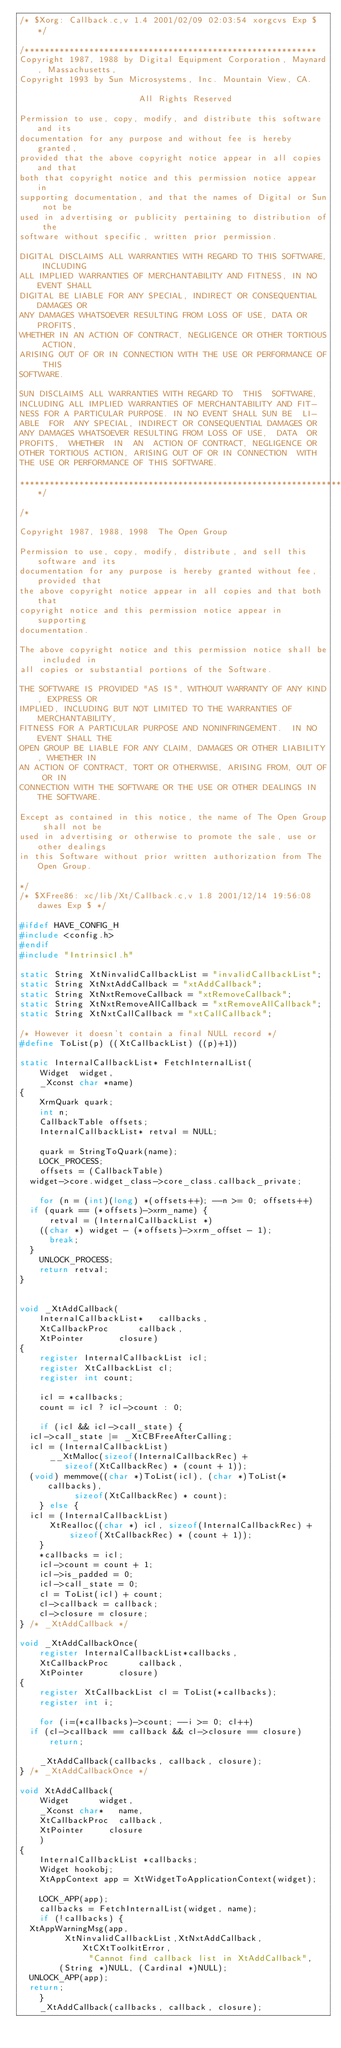<code> <loc_0><loc_0><loc_500><loc_500><_C_>/* $Xorg: Callback.c,v 1.4 2001/02/09 02:03:54 xorgcvs Exp $ */

/***********************************************************
Copyright 1987, 1988 by Digital Equipment Corporation, Maynard, Massachusetts,
Copyright 1993 by Sun Microsystems, Inc. Mountain View, CA.

                        All Rights Reserved

Permission to use, copy, modify, and distribute this software and its
documentation for any purpose and without fee is hereby granted,
provided that the above copyright notice appear in all copies and that
both that copyright notice and this permission notice appear in
supporting documentation, and that the names of Digital or Sun not be
used in advertising or publicity pertaining to distribution of the
software without specific, written prior permission.

DIGITAL DISCLAIMS ALL WARRANTIES WITH REGARD TO THIS SOFTWARE, INCLUDING
ALL IMPLIED WARRANTIES OF MERCHANTABILITY AND FITNESS, IN NO EVENT SHALL
DIGITAL BE LIABLE FOR ANY SPECIAL, INDIRECT OR CONSEQUENTIAL DAMAGES OR
ANY DAMAGES WHATSOEVER RESULTING FROM LOSS OF USE, DATA OR PROFITS,
WHETHER IN AN ACTION OF CONTRACT, NEGLIGENCE OR OTHER TORTIOUS ACTION,
ARISING OUT OF OR IN CONNECTION WITH THE USE OR PERFORMANCE OF THIS
SOFTWARE.

SUN DISCLAIMS ALL WARRANTIES WITH REGARD TO  THIS  SOFTWARE,
INCLUDING ALL IMPLIED WARRANTIES OF MERCHANTABILITY AND FIT-
NESS FOR A PARTICULAR PURPOSE. IN NO EVENT SHALL SUN BE  LI-
ABLE  FOR  ANY SPECIAL, INDIRECT OR CONSEQUENTIAL DAMAGES OR
ANY DAMAGES WHATSOEVER RESULTING FROM LOSS OF USE,  DATA  OR
PROFITS,  WHETHER  IN  AN  ACTION OF CONTRACT, NEGLIGENCE OR
OTHER TORTIOUS ACTION, ARISING OUT OF OR IN CONNECTION  WITH
THE USE OR PERFORMANCE OF THIS SOFTWARE.

******************************************************************/

/*

Copyright 1987, 1988, 1998  The Open Group

Permission to use, copy, modify, distribute, and sell this software and its
documentation for any purpose is hereby granted without fee, provided that
the above copyright notice appear in all copies and that both that
copyright notice and this permission notice appear in supporting
documentation.

The above copyright notice and this permission notice shall be included in
all copies or substantial portions of the Software.

THE SOFTWARE IS PROVIDED "AS IS", WITHOUT WARRANTY OF ANY KIND, EXPRESS OR
IMPLIED, INCLUDING BUT NOT LIMITED TO THE WARRANTIES OF MERCHANTABILITY,
FITNESS FOR A PARTICULAR PURPOSE AND NONINFRINGEMENT.  IN NO EVENT SHALL THE
OPEN GROUP BE LIABLE FOR ANY CLAIM, DAMAGES OR OTHER LIABILITY, WHETHER IN
AN ACTION OF CONTRACT, TORT OR OTHERWISE, ARISING FROM, OUT OF OR IN
CONNECTION WITH THE SOFTWARE OR THE USE OR OTHER DEALINGS IN THE SOFTWARE.

Except as contained in this notice, the name of The Open Group shall not be
used in advertising or otherwise to promote the sale, use or other dealings
in this Software without prior written authorization from The Open Group.

*/
/* $XFree86: xc/lib/Xt/Callback.c,v 1.8 2001/12/14 19:56:08 dawes Exp $ */

#ifdef HAVE_CONFIG_H
#include <config.h>
#endif
#include "IntrinsicI.h"

static String XtNinvalidCallbackList = "invalidCallbackList";
static String XtNxtAddCallback = "xtAddCallback";
static String XtNxtRemoveCallback = "xtRemoveCallback";
static String XtNxtRemoveAllCallback = "xtRemoveAllCallback";
static String XtNxtCallCallback = "xtCallCallback";

/* However it doesn't contain a final NULL record */
#define ToList(p) ((XtCallbackList) ((p)+1))

static InternalCallbackList* FetchInternalList(
    Widget	widget,
    _Xconst char *name)
{
    XrmQuark quark;
    int n;
    CallbackTable offsets;
    InternalCallbackList* retval = NULL;

    quark = StringToQuark(name);
    LOCK_PROCESS;
    offsets = (CallbackTable)
	widget->core.widget_class->core_class.callback_private;

    for (n = (int)(long) *(offsets++); --n >= 0; offsets++)
	if (quark == (*offsets)->xrm_name) {
	    retval = (InternalCallbackList *)
		((char *) widget - (*offsets)->xrm_offset - 1);
	    break;
	}
    UNLOCK_PROCESS;
    return retval;
}


void _XtAddCallback(
    InternalCallbackList*   callbacks,
    XtCallbackProc	    callback,
    XtPointer		    closure)
{
    register InternalCallbackList icl;
    register XtCallbackList cl;
    register int count;

    icl = *callbacks;
    count = icl ? icl->count : 0;

    if (icl && icl->call_state) {
	icl->call_state |= _XtCBFreeAfterCalling;
	icl = (InternalCallbackList)
	    __XtMalloc(sizeof(InternalCallbackRec) +
		     sizeof(XtCallbackRec) * (count + 1));
	(void) memmove((char *)ToList(icl), (char *)ToList(*callbacks),
		       sizeof(XtCallbackRec) * count);
    } else {
	icl = (InternalCallbackList)
	    XtRealloc((char *) icl, sizeof(InternalCallbackRec) +
		      sizeof(XtCallbackRec) * (count + 1));
    }
    *callbacks = icl;
    icl->count = count + 1;
    icl->is_padded = 0;
    icl->call_state = 0;
    cl = ToList(icl) + count;
    cl->callback = callback;
    cl->closure = closure;
} /* _XtAddCallback */

void _XtAddCallbackOnce(
    register InternalCallbackList*callbacks,
    XtCallbackProc	    callback,
    XtPointer		    closure)
{
    register XtCallbackList cl = ToList(*callbacks);
    register int i;

    for (i=(*callbacks)->count; --i >= 0; cl++)
	if (cl->callback == callback && cl->closure == closure)
	    return;

    _XtAddCallback(callbacks, callback, closure);
} /* _XtAddCallbackOnce */

void XtAddCallback(
    Widget	    widget,
    _Xconst char*   name,
    XtCallbackProc  callback,
    XtPointer	    closure
    )
{
    InternalCallbackList *callbacks;
    Widget hookobj;
    XtAppContext app = XtWidgetToApplicationContext(widget);

    LOCK_APP(app);
    callbacks = FetchInternalList(widget, name);
    if (!callbacks) {
	XtAppWarningMsg(app,
	       XtNinvalidCallbackList,XtNxtAddCallback,XtCXtToolkitError,
              "Cannot find callback list in XtAddCallback",
	      (String *)NULL, (Cardinal *)NULL);
	UNLOCK_APP(app);
	return;
    }
    _XtAddCallback(callbacks, callback, closure);</code> 